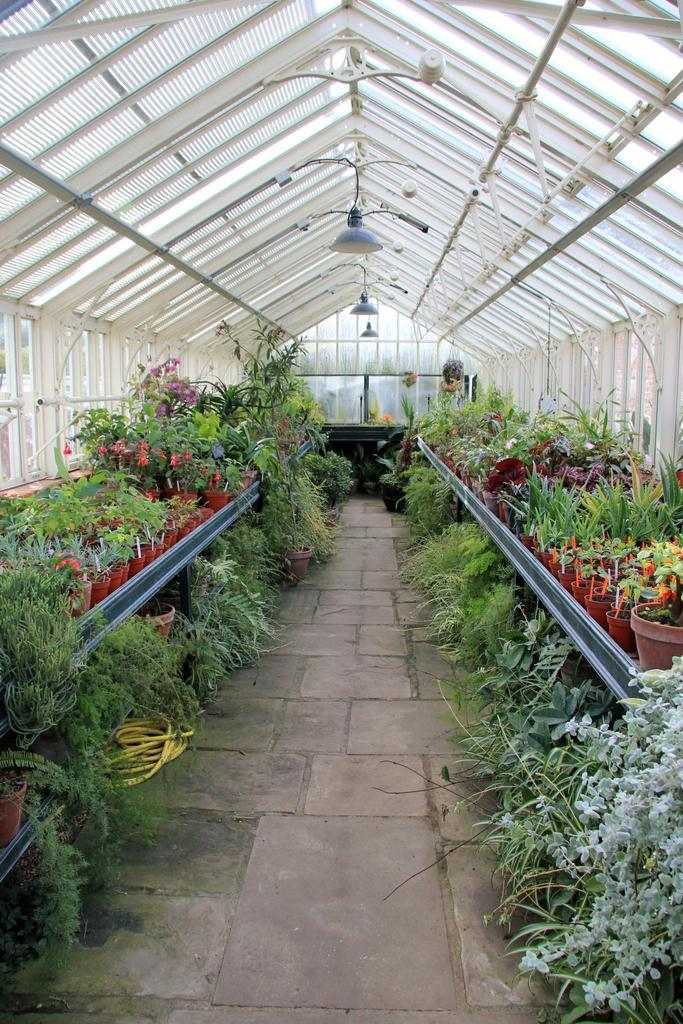What is the main object in the center of the image? There is a plant pot in the center of the image. What types of vegetation can be seen in the image? There are plants and flowers in the image. What safety measure is present in the image? Caution tapes are present in the image. What type of pathway is visible in the image? There is a road in the image. What kind of structure is visible in the background? There is a wall and a roof in the background of the image. What type of lighting is present in the background? There are lamps in the background of the image. How does the yam feel about being in the image? There is no yam present in the image, so it cannot have any feelings about being in the image. 